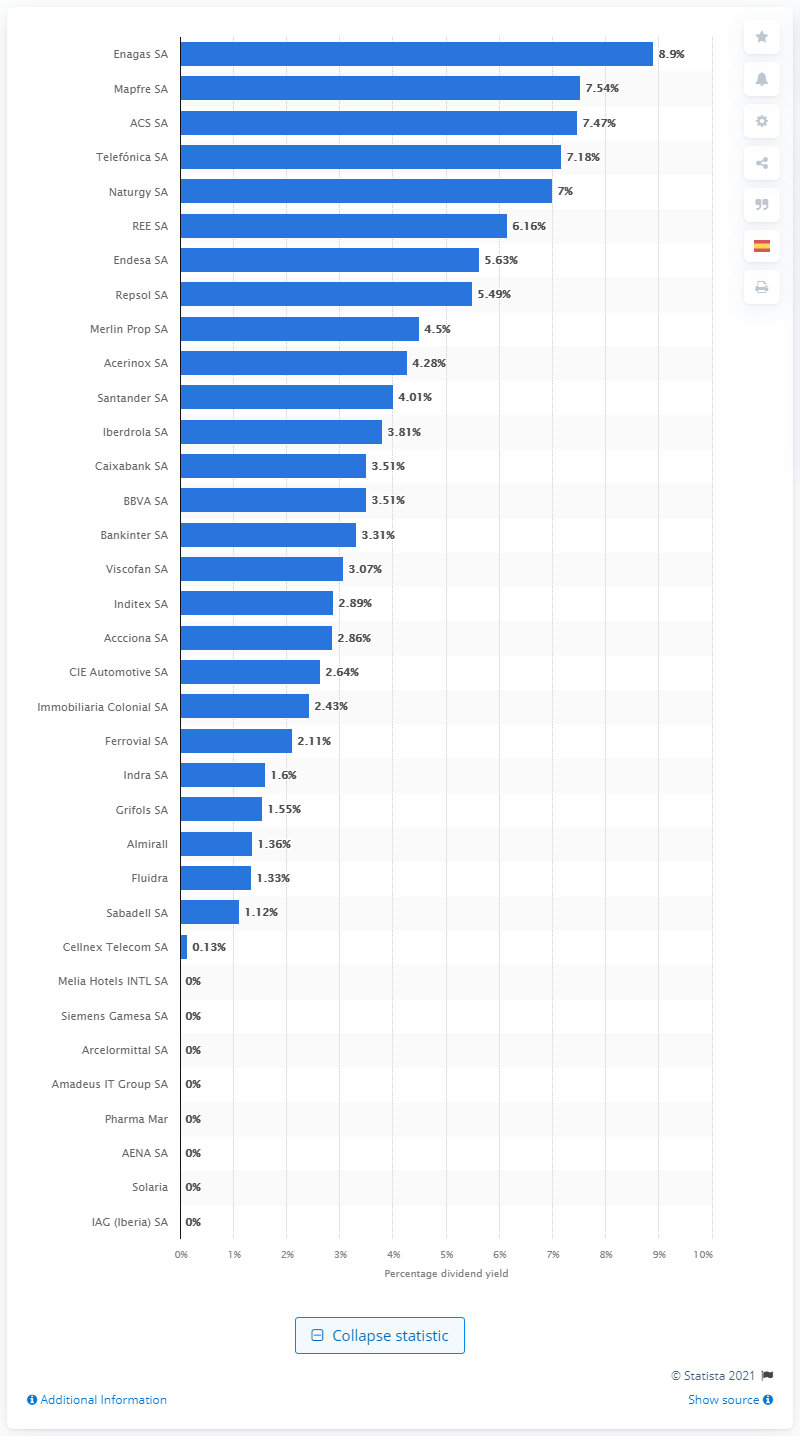Specify some key components in this picture. The expected dividend yield of Enagas SA was 8.9%. At the time of consideration, Enagas SA was determined to have the highest expected dividend yield among energy companies. 